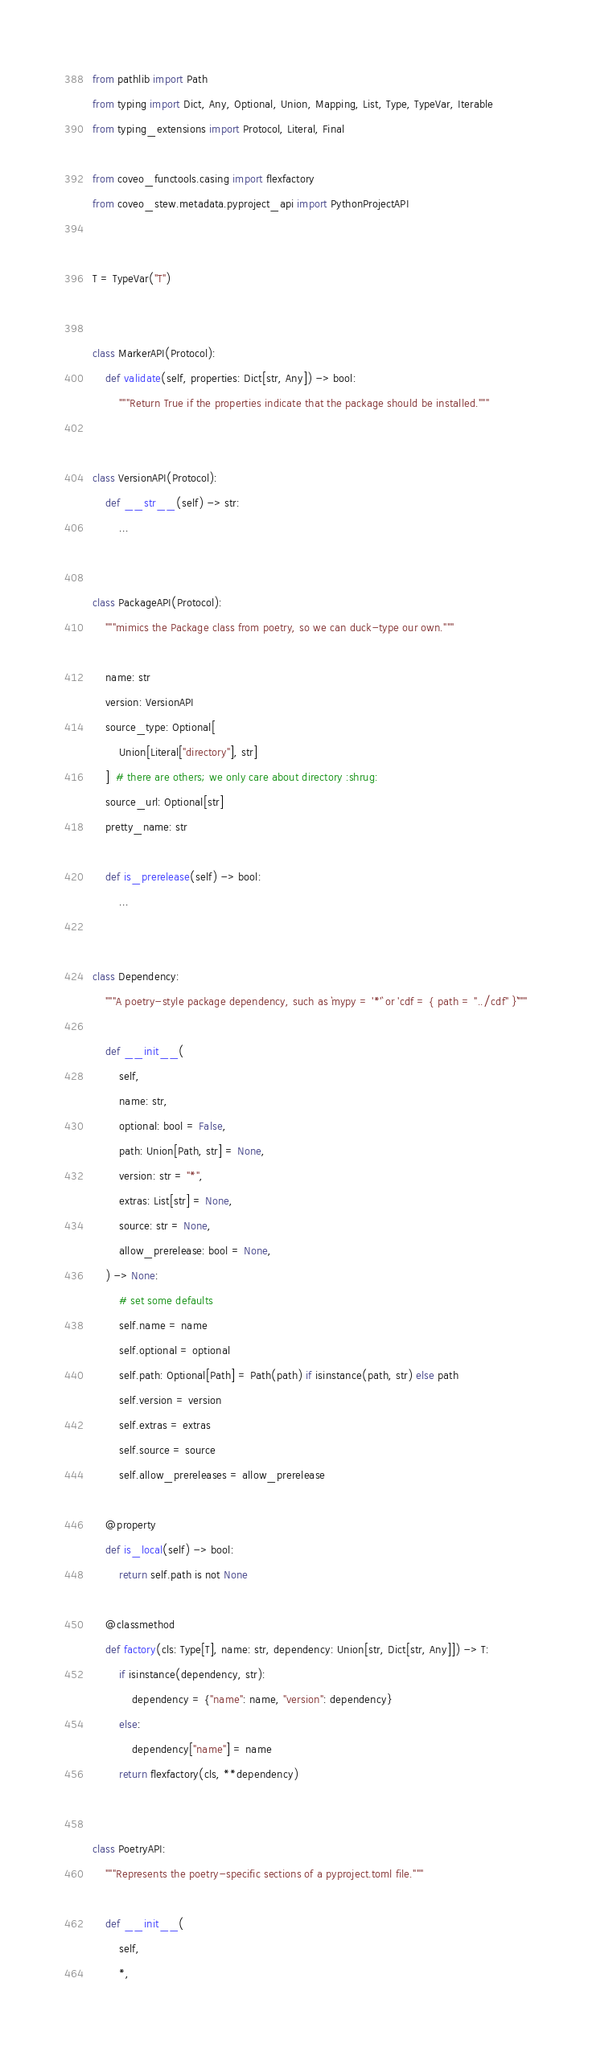Convert code to text. <code><loc_0><loc_0><loc_500><loc_500><_Python_>from pathlib import Path
from typing import Dict, Any, Optional, Union, Mapping, List, Type, TypeVar, Iterable
from typing_extensions import Protocol, Literal, Final

from coveo_functools.casing import flexfactory
from coveo_stew.metadata.pyproject_api import PythonProjectAPI


T = TypeVar("T")


class MarkerAPI(Protocol):
    def validate(self, properties: Dict[str, Any]) -> bool:
        """Return True if the properties indicate that the package should be installed."""


class VersionAPI(Protocol):
    def __str__(self) -> str:
        ...


class PackageAPI(Protocol):
    """mimics the Package class from poetry, so we can duck-type our own."""

    name: str
    version: VersionAPI
    source_type: Optional[
        Union[Literal["directory"], str]
    ]  # there are others; we only care about directory :shrug:
    source_url: Optional[str]
    pretty_name: str

    def is_prerelease(self) -> bool:
        ...


class Dependency:
    """A poetry-style package dependency, such as `mypy = '*'` or 'cdf = { path = "../cdf" }`"""

    def __init__(
        self,
        name: str,
        optional: bool = False,
        path: Union[Path, str] = None,
        version: str = "*",
        extras: List[str] = None,
        source: str = None,
        allow_prerelease: bool = None,
    ) -> None:
        # set some defaults
        self.name = name
        self.optional = optional
        self.path: Optional[Path] = Path(path) if isinstance(path, str) else path
        self.version = version
        self.extras = extras
        self.source = source
        self.allow_prereleases = allow_prerelease

    @property
    def is_local(self) -> bool:
        return self.path is not None

    @classmethod
    def factory(cls: Type[T], name: str, dependency: Union[str, Dict[str, Any]]) -> T:
        if isinstance(dependency, str):
            dependency = {"name": name, "version": dependency}
        else:
            dependency["name"] = name
        return flexfactory(cls, **dependency)


class PoetryAPI:
    """Represents the poetry-specific sections of a pyproject.toml file."""

    def __init__(
        self,
        *,</code> 